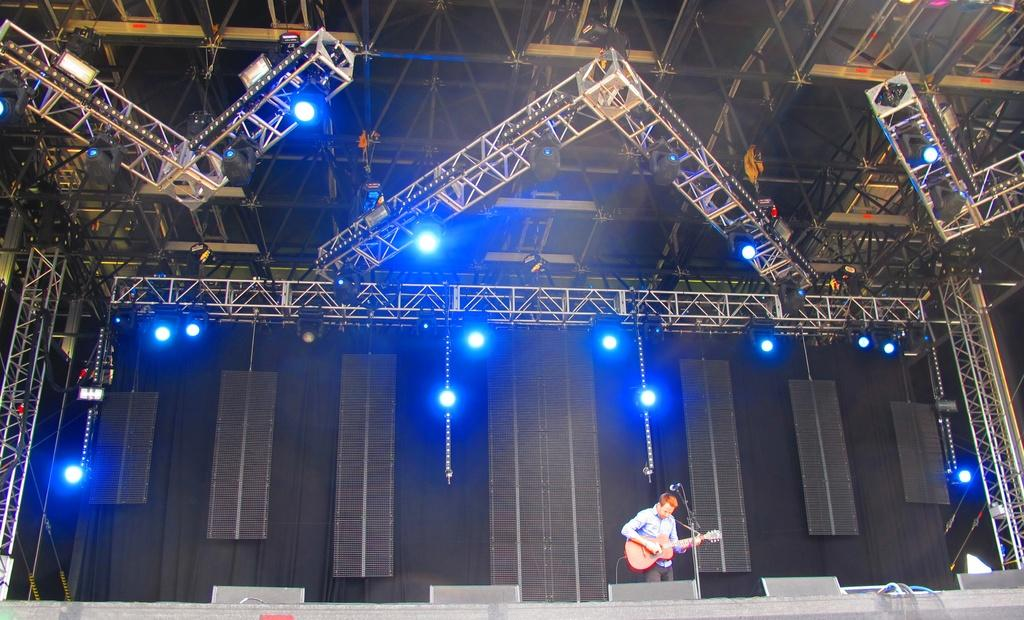What is the man in the image holding? The man is holding a guitar. What is the man standing in front of in the image? The man is standing in front of a microphone. What can be seen in the background of the image? There are many lights and stands that reach the ceiling in the background of the image. What type of tent can be seen in the background of the image? There is no tent present in the image; the background features lights and stands. What kind of club is the man holding in the image? The man is holding a guitar, not a club. 